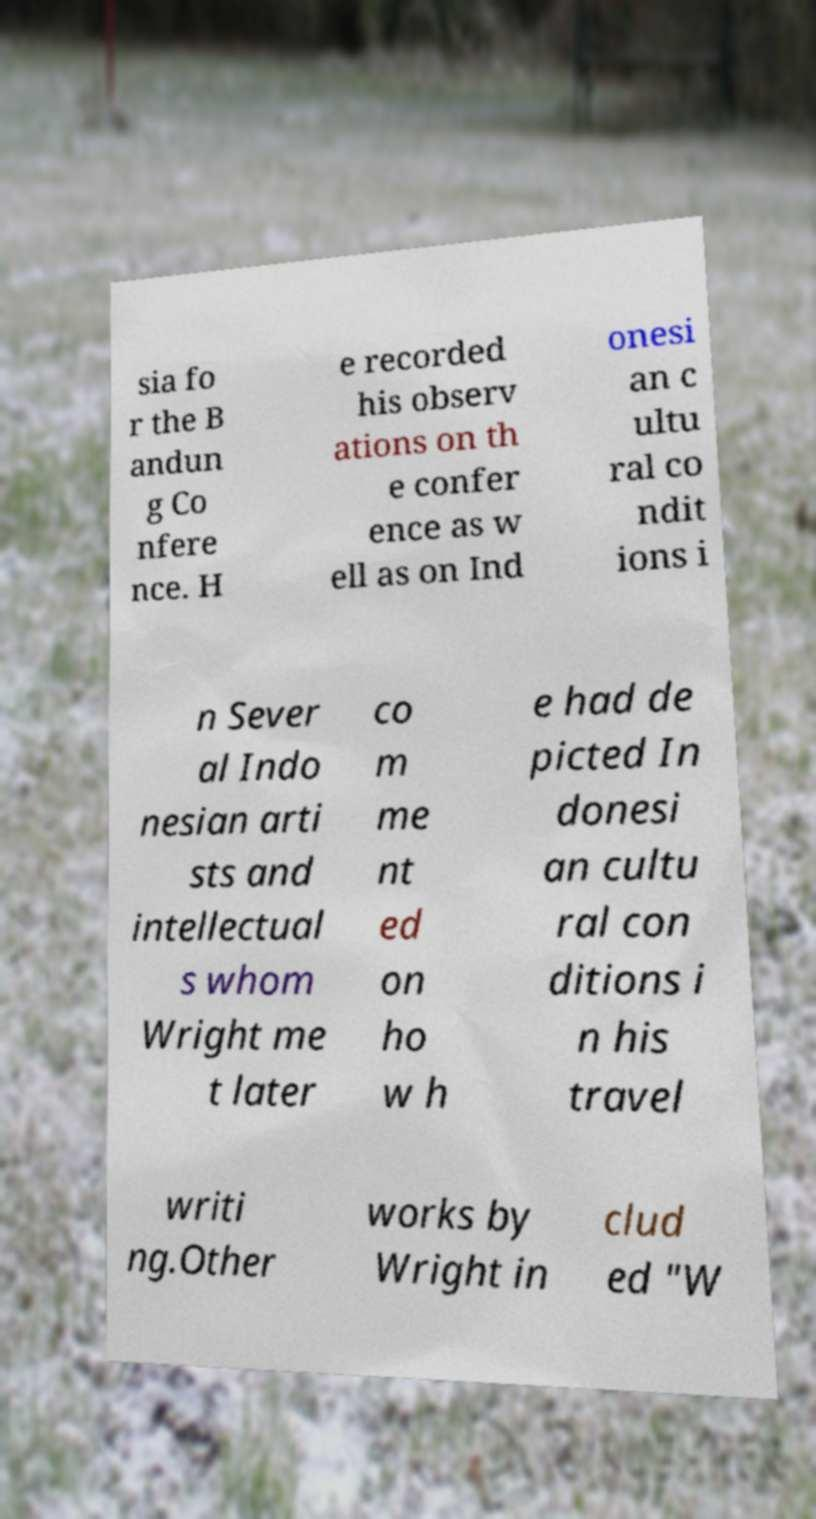Please read and relay the text visible in this image. What does it say? sia fo r the B andun g Co nfere nce. H e recorded his observ ations on th e confer ence as w ell as on Ind onesi an c ultu ral co ndit ions i n Sever al Indo nesian arti sts and intellectual s whom Wright me t later co m me nt ed on ho w h e had de picted In donesi an cultu ral con ditions i n his travel writi ng.Other works by Wright in clud ed "W 